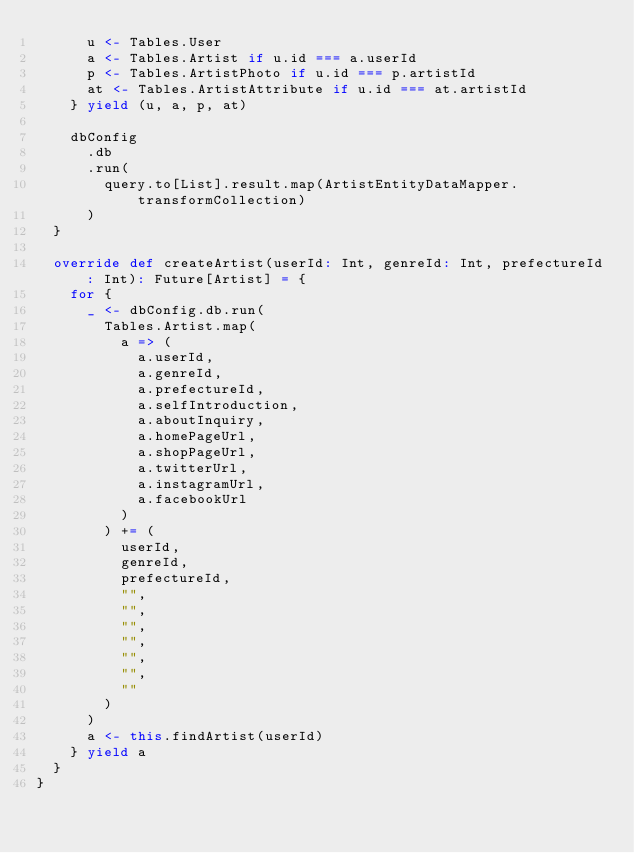Convert code to text. <code><loc_0><loc_0><loc_500><loc_500><_Scala_>      u <- Tables.User
      a <- Tables.Artist if u.id === a.userId
      p <- Tables.ArtistPhoto if u.id === p.artistId
      at <- Tables.ArtistAttribute if u.id === at.artistId
    } yield (u, a, p, at)

    dbConfig
      .db
      .run(
        query.to[List].result.map(ArtistEntityDataMapper.transformCollection)
      )
  }

  override def createArtist(userId: Int, genreId: Int, prefectureId: Int): Future[Artist] = {
    for {
      _ <- dbConfig.db.run(
        Tables.Artist.map(
          a => (
            a.userId,
            a.genreId,
            a.prefectureId,
            a.selfIntroduction,
            a.aboutInquiry,
            a.homePageUrl,
            a.shopPageUrl,
            a.twitterUrl,
            a.instagramUrl,
            a.facebookUrl
          )
        ) += (
          userId,
          genreId,
          prefectureId,
          "",
          "",
          "",
          "",
          "",
          "",
          ""
        )
      )
      a <- this.findArtist(userId)
    } yield a
  }
}

</code> 